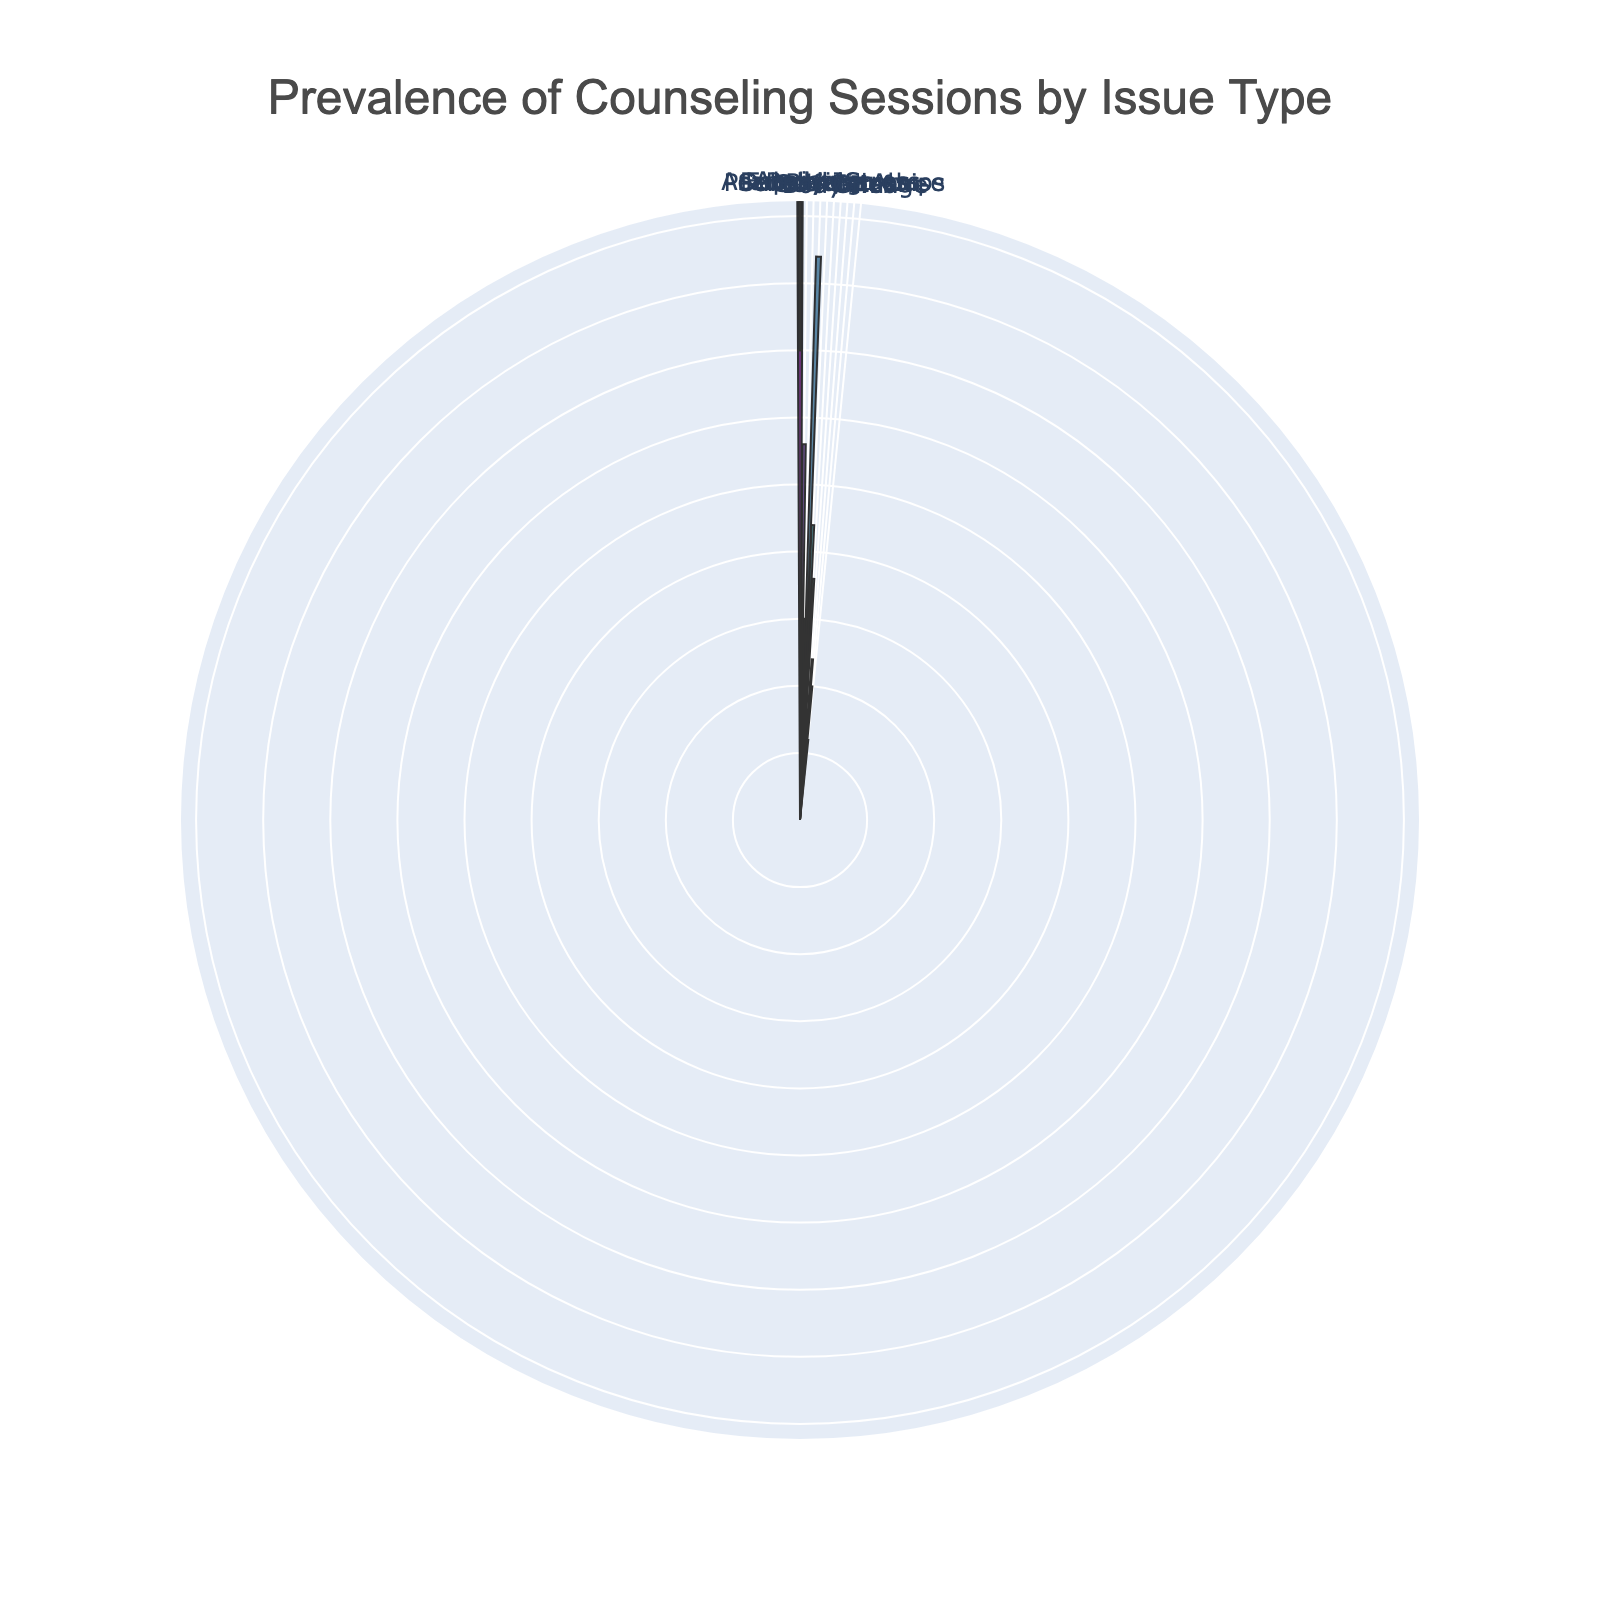What issue type has the highest number of counseling sessions? By examining the lengths of bars around the rose chart, we can see that 'Academic Stress' has the most extended radius. Hence, 'Academic Stress' has the highest number of sessions.
Answer: Academic Stress How many counseling sessions are attributed to Substance Abuse? Looking at the length of the bar corresponding to 'Substance Abuse' and the hover text on that segment, we can see it is the shortest and has 8 sessions.
Answer: 8 What is the combined number of counseling sessions for Anxiety and Depression? The bar length for 'Anxiety' and 'Depression', as well as their hover texts, show counts of 35 and 28, respectively. Their sum is 35 + 28 = 63.
Answer: 63 Which issue has fewer counseling sessions, Bullying or Self-Esteem? Comparing the bar lengths for 'Bullying' and 'Self-Esteem' in the rose chart, we see 'Bullying' has 15 sessions, while 'Self-Esteem' has 12 sessions. Thus, 'Self-Esteem' has fewer sessions.
Answer: Self-Esteem What are the three least prevalent issues according to the chart? Identify the three shortest bars in the rose chart. From shortest to next, they are 'Grief' (6 sessions), 'Substance Abuse' (8 sessions), and 'Body Image' (10 sessions).
Answer: Grief, Substance Abuse, Body Image How many more counseling sessions are conducted for Academic Stress than for Family Issues? 'Academic Stress' has 42 sessions, and 'Family Issues' have 22 sessions. The difference is 42 - 22 = 20.
Answer: 20 What percentage of the total counseling sessions are for Peer Relationships? Calculate the total number of sessions. Sum all the counts: 35 + 28 + 15 + 42 + 22 + 18 + 8 + 12 + 10 + 6 = 196. Then, the percentage for Peer Relationships is (18 / 196) * 100 ≈ 9.18%.
Answer: 9.18% Which issue type's bar is colored halfway between the lightest and darkest sections of the Viridis palette? By observation, 'Family Issues' appears to fall in the midpoint between the lightest and darkest colors in the Viridis palette.
Answer: Family Issues 